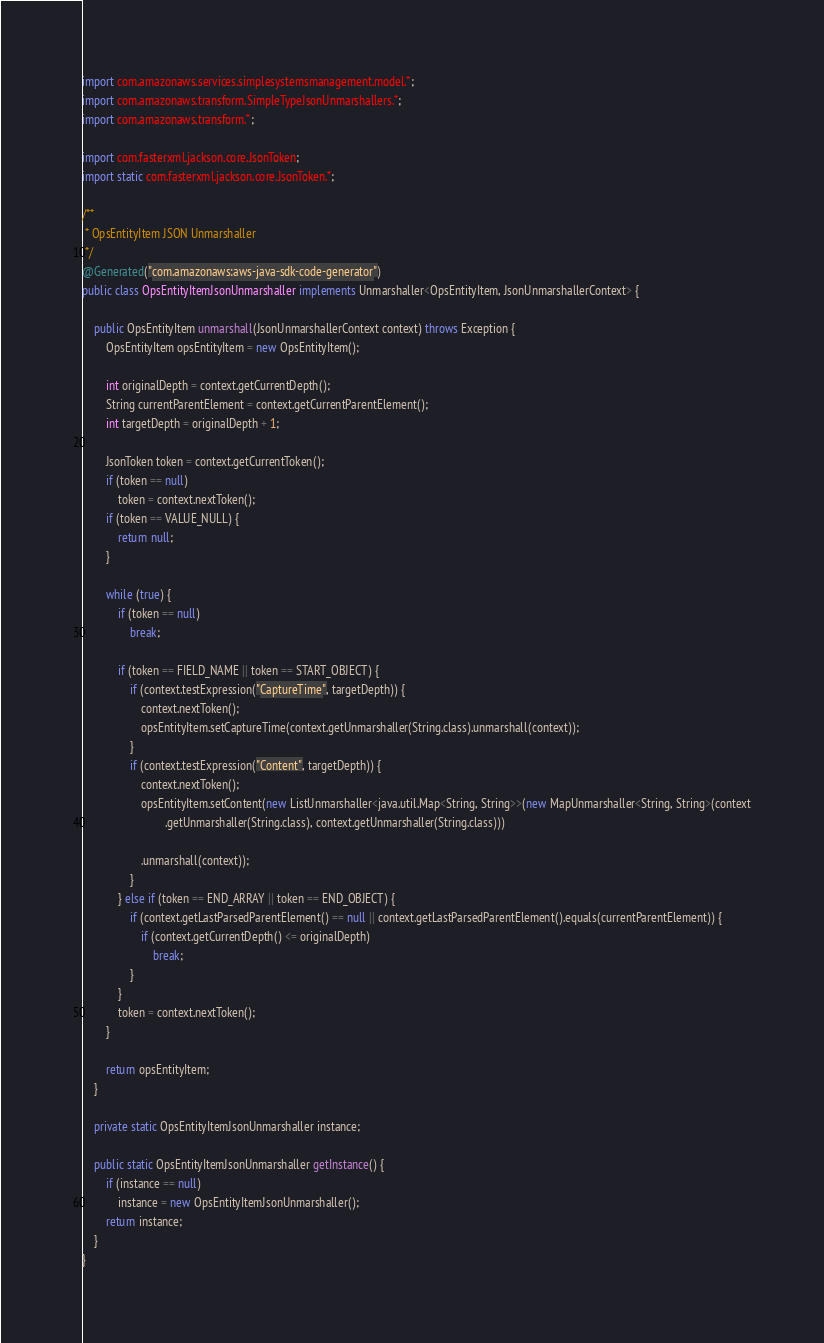Convert code to text. <code><loc_0><loc_0><loc_500><loc_500><_Java_>
import com.amazonaws.services.simplesystemsmanagement.model.*;
import com.amazonaws.transform.SimpleTypeJsonUnmarshallers.*;
import com.amazonaws.transform.*;

import com.fasterxml.jackson.core.JsonToken;
import static com.fasterxml.jackson.core.JsonToken.*;

/**
 * OpsEntityItem JSON Unmarshaller
 */
@Generated("com.amazonaws:aws-java-sdk-code-generator")
public class OpsEntityItemJsonUnmarshaller implements Unmarshaller<OpsEntityItem, JsonUnmarshallerContext> {

    public OpsEntityItem unmarshall(JsonUnmarshallerContext context) throws Exception {
        OpsEntityItem opsEntityItem = new OpsEntityItem();

        int originalDepth = context.getCurrentDepth();
        String currentParentElement = context.getCurrentParentElement();
        int targetDepth = originalDepth + 1;

        JsonToken token = context.getCurrentToken();
        if (token == null)
            token = context.nextToken();
        if (token == VALUE_NULL) {
            return null;
        }

        while (true) {
            if (token == null)
                break;

            if (token == FIELD_NAME || token == START_OBJECT) {
                if (context.testExpression("CaptureTime", targetDepth)) {
                    context.nextToken();
                    opsEntityItem.setCaptureTime(context.getUnmarshaller(String.class).unmarshall(context));
                }
                if (context.testExpression("Content", targetDepth)) {
                    context.nextToken();
                    opsEntityItem.setContent(new ListUnmarshaller<java.util.Map<String, String>>(new MapUnmarshaller<String, String>(context
                            .getUnmarshaller(String.class), context.getUnmarshaller(String.class)))

                    .unmarshall(context));
                }
            } else if (token == END_ARRAY || token == END_OBJECT) {
                if (context.getLastParsedParentElement() == null || context.getLastParsedParentElement().equals(currentParentElement)) {
                    if (context.getCurrentDepth() <= originalDepth)
                        break;
                }
            }
            token = context.nextToken();
        }

        return opsEntityItem;
    }

    private static OpsEntityItemJsonUnmarshaller instance;

    public static OpsEntityItemJsonUnmarshaller getInstance() {
        if (instance == null)
            instance = new OpsEntityItemJsonUnmarshaller();
        return instance;
    }
}
</code> 